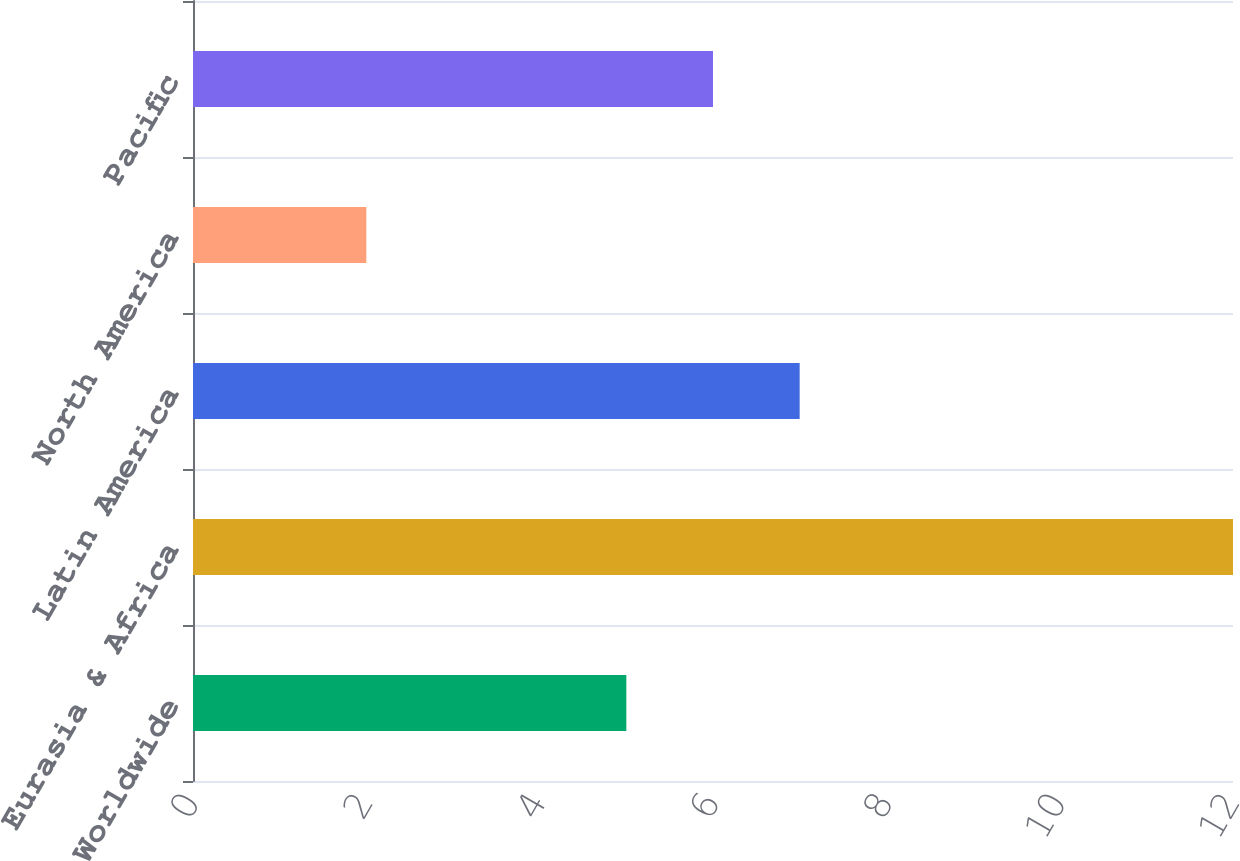<chart> <loc_0><loc_0><loc_500><loc_500><bar_chart><fcel>Worldwide<fcel>Eurasia & Africa<fcel>Latin America<fcel>North America<fcel>Pacific<nl><fcel>5<fcel>12<fcel>7<fcel>2<fcel>6<nl></chart> 